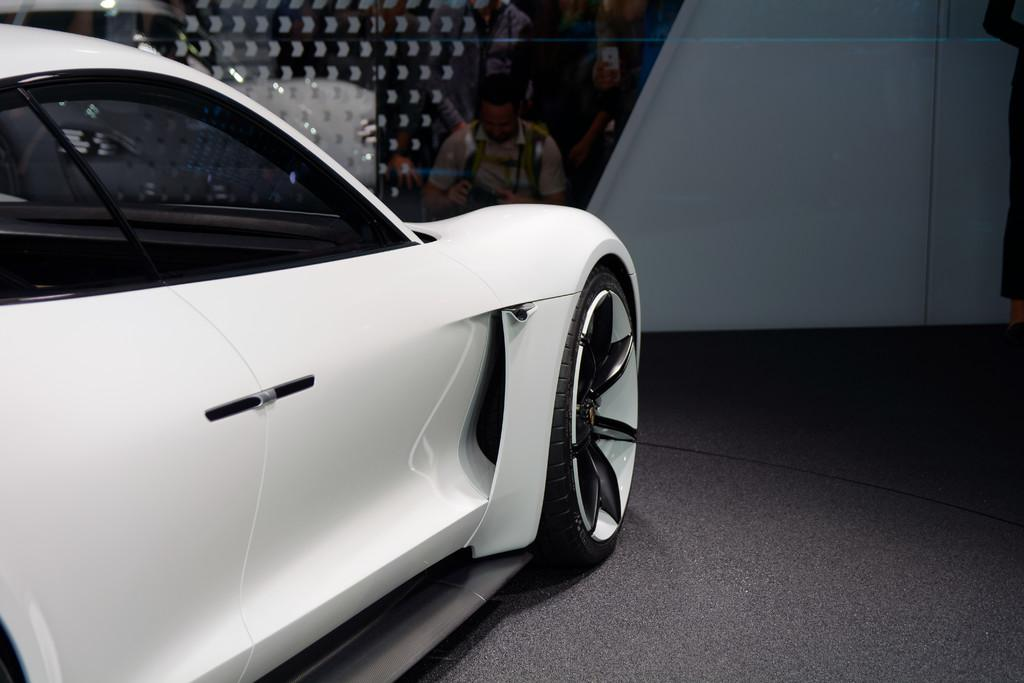What type of vehicle is in the image? There is a white color car in the image. Can you describe the man's position in the image? There is a man sitting near a wall in the image. What type of rifle is the man holding in the image? There is no rifle present in the image; the man is simply sitting near a wall. 